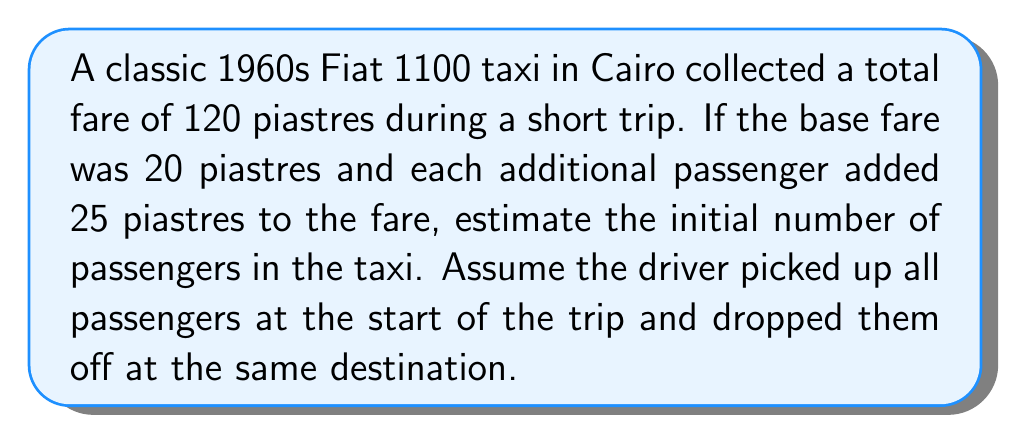Teach me how to tackle this problem. Let's approach this step-by-step:

1) Let $x$ be the number of passengers.

2) The total fare can be expressed as:
   $$\text{Total Fare} = \text{Base Fare} + \text{Additional Passenger Fare}$$

3) We know the total fare is 120 piastres and the base fare is 20 piastres. Each additional passenger adds 25 piastres. We can express this as an equation:

   $$120 = 20 + 25(x-1)$$

4) The $(x-1)$ term is used because the first passenger is included in the base fare, so we only count additional passengers.

5) Let's solve the equation:
   $$\begin{align}
   120 &= 20 + 25(x-1) \\
   100 &= 25(x-1) \\
   4 &= x-1 \\
   x &= 5
   \end{align}$$

6) Therefore, the estimated number of initial passengers is 5.

This inverse problem involves working backwards from the total fare to determine the number of passengers, which is a common scenario in real-world applications of mathematics.
Answer: 5 passengers 